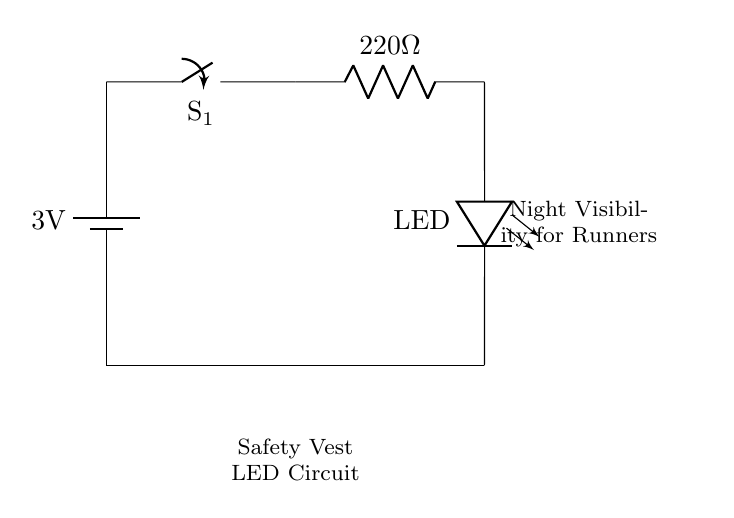What is the voltage of the battery? The battery is labeled with a voltage of 3 volts, which means it supplies this amount of potential difference to the circuit.
Answer: 3 volts What type of switch is used in this circuit? The diagram indicates a simple switch labeled as S1, which typically allows the circuit to open or close, controlling the flow of electricity.
Answer: Switch What is the purpose of the resistor in this circuit? The resistor is present to limit the current flowing to the LED. Using a resistor helps prevent excessive current that could damage the LED.
Answer: Limit current How is the LED connected in the circuit? The LED is connected in a series configuration between the resistor and ground, allowing current to flow through it when the switch is closed.
Answer: Series What is the resistance value of the resistor? The resistance value is indicated in the diagram as 220 ohms, which impacts the current flowing to the LED.
Answer: 220 ohms What does the LED represent in the circuit? The LED's purpose is to illuminate when current flows through it, providing night visibility for runners wearing the vest.
Answer: Illuminate Why is this circuit important for a runner's safety vest? This circuit increases visibility in low-light conditions, making it safer for runners by making them more noticeable to others.
Answer: Night visibility 